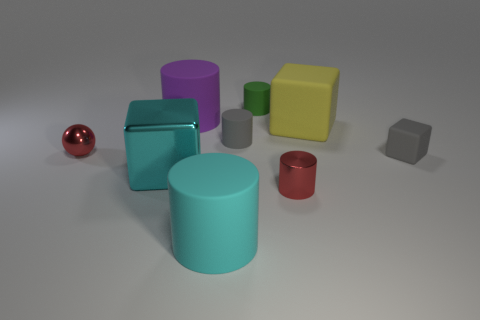Subtract all large rubber cubes. How many cubes are left? 2 Add 1 cyan objects. How many objects exist? 10 Subtract all purple cylinders. How many cylinders are left? 4 Subtract all spheres. How many objects are left? 8 Add 4 tiny rubber cylinders. How many tiny rubber cylinders exist? 6 Subtract 0 blue balls. How many objects are left? 9 Subtract all green spheres. Subtract all green cylinders. How many spheres are left? 1 Subtract all small red metal cylinders. Subtract all cyan metal blocks. How many objects are left? 7 Add 7 green cylinders. How many green cylinders are left? 8 